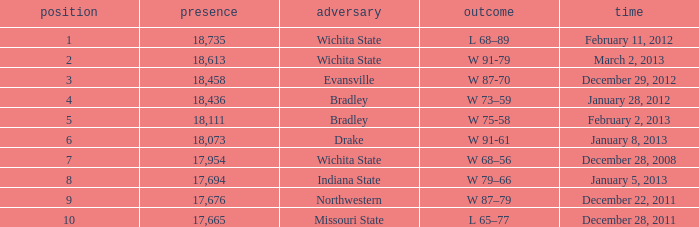What's the rank for February 11, 2012 with less than 18,735 in attendance? None. 